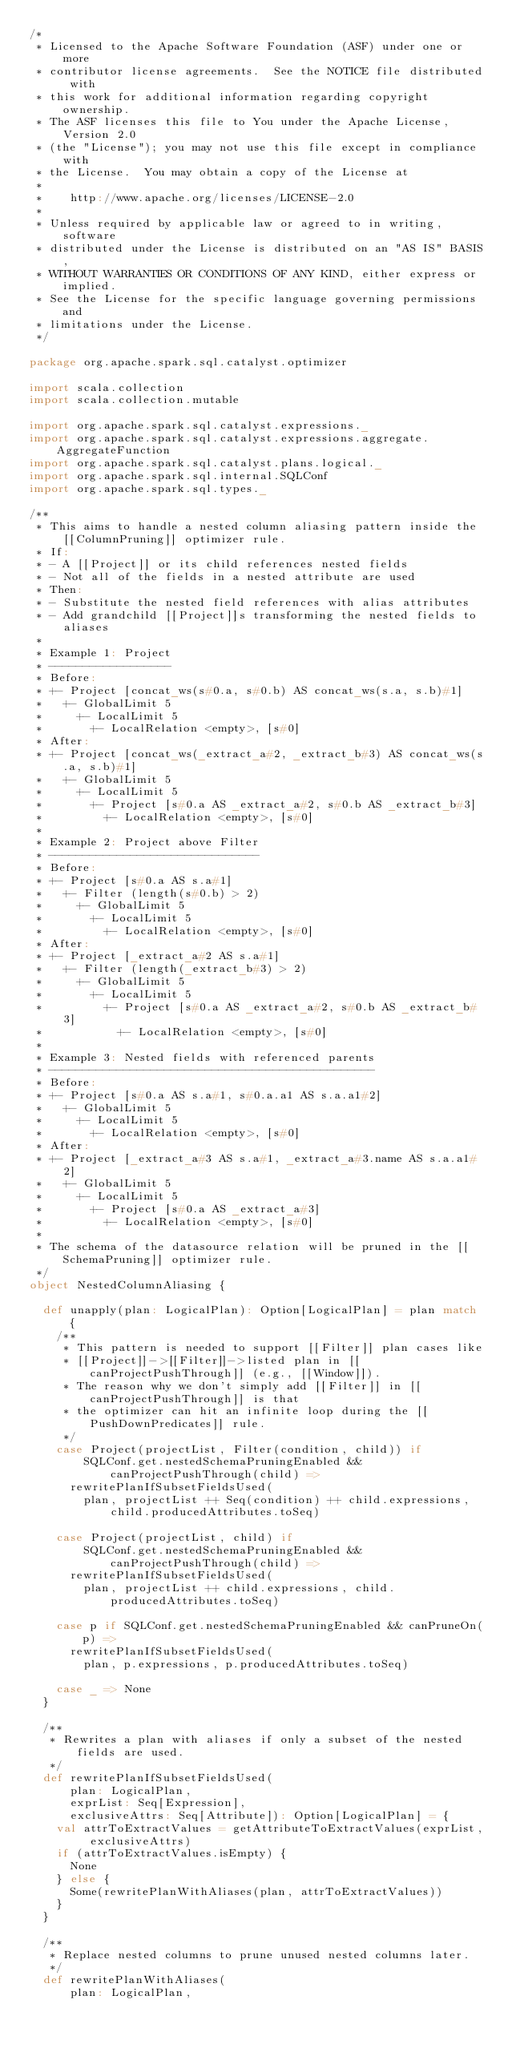<code> <loc_0><loc_0><loc_500><loc_500><_Scala_>/*
 * Licensed to the Apache Software Foundation (ASF) under one or more
 * contributor license agreements.  See the NOTICE file distributed with
 * this work for additional information regarding copyright ownership.
 * The ASF licenses this file to You under the Apache License, Version 2.0
 * (the "License"); you may not use this file except in compliance with
 * the License.  You may obtain a copy of the License at
 *
 *    http://www.apache.org/licenses/LICENSE-2.0
 *
 * Unless required by applicable law or agreed to in writing, software
 * distributed under the License is distributed on an "AS IS" BASIS,
 * WITHOUT WARRANTIES OR CONDITIONS OF ANY KIND, either express or implied.
 * See the License for the specific language governing permissions and
 * limitations under the License.
 */

package org.apache.spark.sql.catalyst.optimizer

import scala.collection
import scala.collection.mutable

import org.apache.spark.sql.catalyst.expressions._
import org.apache.spark.sql.catalyst.expressions.aggregate.AggregateFunction
import org.apache.spark.sql.catalyst.plans.logical._
import org.apache.spark.sql.internal.SQLConf
import org.apache.spark.sql.types._

/**
 * This aims to handle a nested column aliasing pattern inside the [[ColumnPruning]] optimizer rule.
 * If:
 * - A [[Project]] or its child references nested fields
 * - Not all of the fields in a nested attribute are used
 * Then:
 * - Substitute the nested field references with alias attributes
 * - Add grandchild [[Project]]s transforming the nested fields to aliases
 *
 * Example 1: Project
 * ------------------
 * Before:
 * +- Project [concat_ws(s#0.a, s#0.b) AS concat_ws(s.a, s.b)#1]
 *   +- GlobalLimit 5
 *     +- LocalLimit 5
 *       +- LocalRelation <empty>, [s#0]
 * After:
 * +- Project [concat_ws(_extract_a#2, _extract_b#3) AS concat_ws(s.a, s.b)#1]
 *   +- GlobalLimit 5
 *     +- LocalLimit 5
 *       +- Project [s#0.a AS _extract_a#2, s#0.b AS _extract_b#3]
 *         +- LocalRelation <empty>, [s#0]
 *
 * Example 2: Project above Filter
 * -------------------------------
 * Before:
 * +- Project [s#0.a AS s.a#1]
 *   +- Filter (length(s#0.b) > 2)
 *     +- GlobalLimit 5
 *       +- LocalLimit 5
 *         +- LocalRelation <empty>, [s#0]
 * After:
 * +- Project [_extract_a#2 AS s.a#1]
 *   +- Filter (length(_extract_b#3) > 2)
 *     +- GlobalLimit 5
 *       +- LocalLimit 5
 *         +- Project [s#0.a AS _extract_a#2, s#0.b AS _extract_b#3]
 *           +- LocalRelation <empty>, [s#0]
 *
 * Example 3: Nested fields with referenced parents
 * ------------------------------------------------
 * Before:
 * +- Project [s#0.a AS s.a#1, s#0.a.a1 AS s.a.a1#2]
 *   +- GlobalLimit 5
 *     +- LocalLimit 5
 *       +- LocalRelation <empty>, [s#0]
 * After:
 * +- Project [_extract_a#3 AS s.a#1, _extract_a#3.name AS s.a.a1#2]
 *   +- GlobalLimit 5
 *     +- LocalLimit 5
 *       +- Project [s#0.a AS _extract_a#3]
 *         +- LocalRelation <empty>, [s#0]
 *
 * The schema of the datasource relation will be pruned in the [[SchemaPruning]] optimizer rule.
 */
object NestedColumnAliasing {

  def unapply(plan: LogicalPlan): Option[LogicalPlan] = plan match {
    /**
     * This pattern is needed to support [[Filter]] plan cases like
     * [[Project]]->[[Filter]]->listed plan in [[canProjectPushThrough]] (e.g., [[Window]]).
     * The reason why we don't simply add [[Filter]] in [[canProjectPushThrough]] is that
     * the optimizer can hit an infinite loop during the [[PushDownPredicates]] rule.
     */
    case Project(projectList, Filter(condition, child)) if
        SQLConf.get.nestedSchemaPruningEnabled && canProjectPushThrough(child) =>
      rewritePlanIfSubsetFieldsUsed(
        plan, projectList ++ Seq(condition) ++ child.expressions, child.producedAttributes.toSeq)

    case Project(projectList, child) if
        SQLConf.get.nestedSchemaPruningEnabled && canProjectPushThrough(child) =>
      rewritePlanIfSubsetFieldsUsed(
        plan, projectList ++ child.expressions, child.producedAttributes.toSeq)

    case p if SQLConf.get.nestedSchemaPruningEnabled && canPruneOn(p) =>
      rewritePlanIfSubsetFieldsUsed(
        plan, p.expressions, p.producedAttributes.toSeq)

    case _ => None
  }

  /**
   * Rewrites a plan with aliases if only a subset of the nested fields are used.
   */
  def rewritePlanIfSubsetFieldsUsed(
      plan: LogicalPlan,
      exprList: Seq[Expression],
      exclusiveAttrs: Seq[Attribute]): Option[LogicalPlan] = {
    val attrToExtractValues = getAttributeToExtractValues(exprList, exclusiveAttrs)
    if (attrToExtractValues.isEmpty) {
      None
    } else {
      Some(rewritePlanWithAliases(plan, attrToExtractValues))
    }
  }

  /**
   * Replace nested columns to prune unused nested columns later.
   */
  def rewritePlanWithAliases(
      plan: LogicalPlan,</code> 